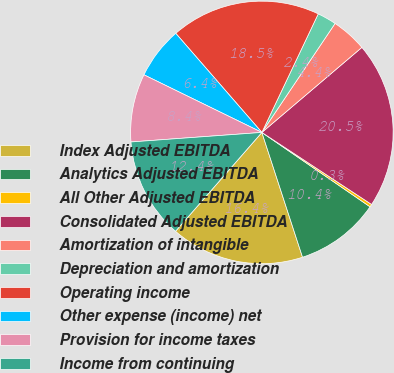Convert chart. <chart><loc_0><loc_0><loc_500><loc_500><pie_chart><fcel>Index Adjusted EBITDA<fcel>Analytics Adjusted EBITDA<fcel>All Other Adjusted EBITDA<fcel>Consolidated Adjusted EBITDA<fcel>Amortization of intangible<fcel>Depreciation and amortization<fcel>Operating income<fcel>Other expense (income) net<fcel>Provision for income taxes<fcel>Income from continuing<nl><fcel>16.44%<fcel>10.4%<fcel>0.34%<fcel>20.46%<fcel>4.37%<fcel>2.35%<fcel>18.45%<fcel>6.38%<fcel>8.39%<fcel>12.41%<nl></chart> 